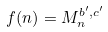<formula> <loc_0><loc_0><loc_500><loc_500>f ( n ) = M _ { n } ^ { b ^ { \prime } , c ^ { \prime } }</formula> 